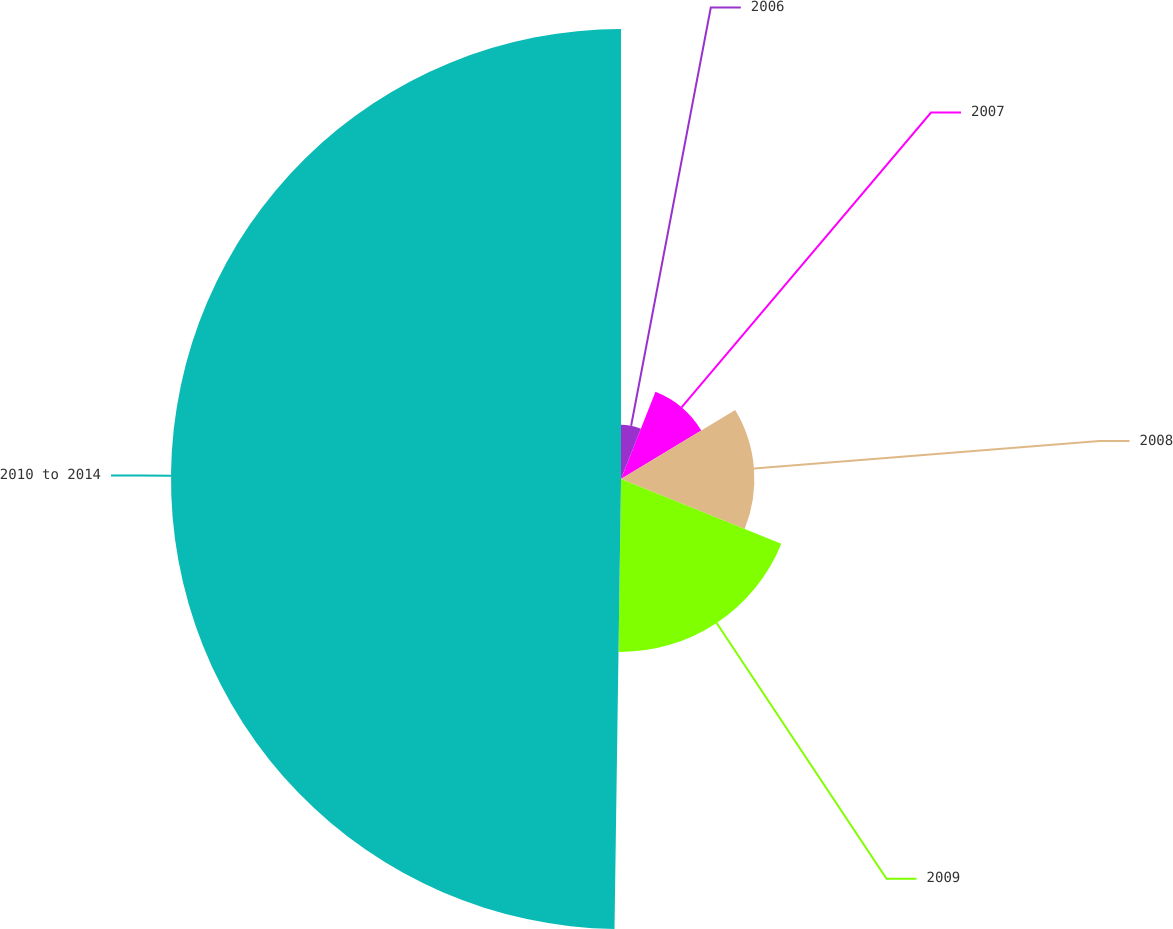Convert chart. <chart><loc_0><loc_0><loc_500><loc_500><pie_chart><fcel>2006<fcel>2007<fcel>2008<fcel>2009<fcel>2010 to 2014<nl><fcel>5.99%<fcel>10.37%<fcel>14.75%<fcel>19.12%<fcel>49.77%<nl></chart> 